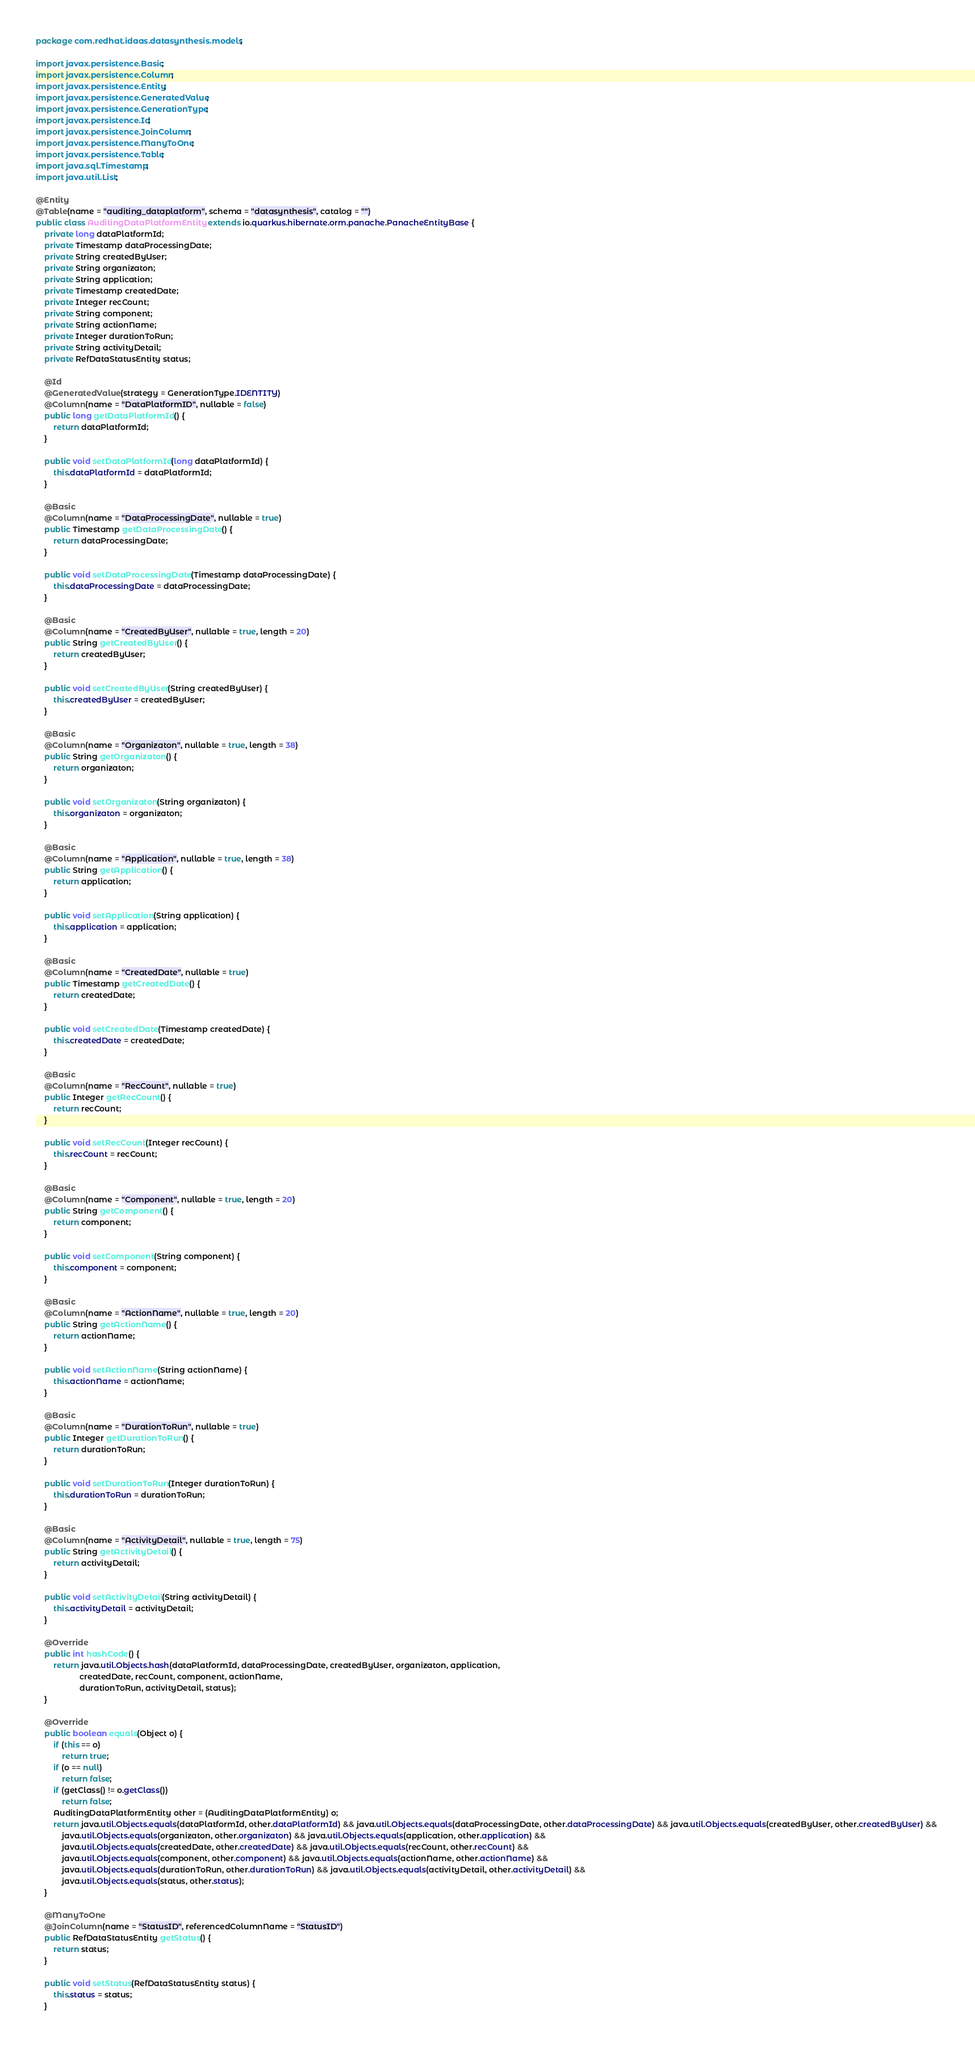<code> <loc_0><loc_0><loc_500><loc_500><_Java_>package com.redhat.idaas.datasynthesis.models;

import javax.persistence.Basic;
import javax.persistence.Column;
import javax.persistence.Entity;
import javax.persistence.GeneratedValue;
import javax.persistence.GenerationType;
import javax.persistence.Id;
import javax.persistence.JoinColumn;
import javax.persistence.ManyToOne;
import javax.persistence.Table;
import java.sql.Timestamp;
import java.util.List;

@Entity
@Table(name = "auditing_dataplatform", schema = "datasynthesis", catalog = "")
public class AuditingDataPlatformEntity extends io.quarkus.hibernate.orm.panache.PanacheEntityBase {
    private long dataPlatformId;
    private Timestamp dataProcessingDate;
    private String createdByUser;
    private String organizaton;
    private String application;
    private Timestamp createdDate;
    private Integer recCount;
    private String component;
    private String actionName;
    private Integer durationToRun;
    private String activityDetail;
    private RefDataStatusEntity status;

    @Id
    @GeneratedValue(strategy = GenerationType.IDENTITY)
    @Column(name = "DataPlatformID", nullable = false)
    public long getDataPlatformId() {
        return dataPlatformId;
    }

    public void setDataPlatformId(long dataPlatformId) {
        this.dataPlatformId = dataPlatformId;
    }

    @Basic
    @Column(name = "DataProcessingDate", nullable = true)
    public Timestamp getDataProcessingDate() {
        return dataProcessingDate;
    }

    public void setDataProcessingDate(Timestamp dataProcessingDate) {
        this.dataProcessingDate = dataProcessingDate;
    }

    @Basic
    @Column(name = "CreatedByUser", nullable = true, length = 20)
    public String getCreatedByUser() {
        return createdByUser;
    }

    public void setCreatedByUser(String createdByUser) {
        this.createdByUser = createdByUser;
    }

    @Basic
    @Column(name = "Organizaton", nullable = true, length = 38)
    public String getOrganizaton() {
        return organizaton;
    }

    public void setOrganizaton(String organizaton) {
        this.organizaton = organizaton;
    }

    @Basic
    @Column(name = "Application", nullable = true, length = 38)
    public String getApplication() {
        return application;
    }

    public void setApplication(String application) {
        this.application = application;
    }

    @Basic
    @Column(name = "CreatedDate", nullable = true)
    public Timestamp getCreatedDate() {
        return createdDate;
    }

    public void setCreatedDate(Timestamp createdDate) {
        this.createdDate = createdDate;
    }

    @Basic
    @Column(name = "RecCount", nullable = true)
    public Integer getRecCount() {
        return recCount;
    }

    public void setRecCount(Integer recCount) {
        this.recCount = recCount;
    }

    @Basic
    @Column(name = "Component", nullable = true, length = 20)
    public String getComponent() {
        return component;
    }

    public void setComponent(String component) {
        this.component = component;
    }

    @Basic
    @Column(name = "ActionName", nullable = true, length = 20)
    public String getActionName() {
        return actionName;
    }

    public void setActionName(String actionName) {
        this.actionName = actionName;
    }

    @Basic
    @Column(name = "DurationToRun", nullable = true)
    public Integer getDurationToRun() {
        return durationToRun;
    }

    public void setDurationToRun(Integer durationToRun) {
        this.durationToRun = durationToRun;
    }

    @Basic
    @Column(name = "ActivityDetail", nullable = true, length = 75)
    public String getActivityDetail() {
        return activityDetail;
    }

    public void setActivityDetail(String activityDetail) {
        this.activityDetail = activityDetail;
    }

    @Override
    public int hashCode() {
		return java.util.Objects.hash(dataPlatformId, dataProcessingDate, createdByUser, organizaton, application,
					createdDate, recCount, component, actionName,
					durationToRun, activityDetail, status);
	}

    @Override
    public boolean equals(Object o) {
		if (this == o)
			return true;
		if (o == null)
			return false;
		if (getClass() != o.getClass())
			return false;
		AuditingDataPlatformEntity other = (AuditingDataPlatformEntity) o;
		return java.util.Objects.equals(dataPlatformId, other.dataPlatformId) && java.util.Objects.equals(dataProcessingDate, other.dataProcessingDate) && java.util.Objects.equals(createdByUser, other.createdByUser) && 
			java.util.Objects.equals(organizaton, other.organizaton) && java.util.Objects.equals(application, other.application) && 
			java.util.Objects.equals(createdDate, other.createdDate) && java.util.Objects.equals(recCount, other.recCount) && 
			java.util.Objects.equals(component, other.component) && java.util.Objects.equals(actionName, other.actionName) && 
			java.util.Objects.equals(durationToRun, other.durationToRun) && java.util.Objects.equals(activityDetail, other.activityDetail) && 
			java.util.Objects.equals(status, other.status);
	}

    @ManyToOne
    @JoinColumn(name = "StatusID", referencedColumnName = "StatusID")
    public RefDataStatusEntity getStatus() {
        return status;
    }

    public void setStatus(RefDataStatusEntity status) {
        this.status = status;
    }
</code> 